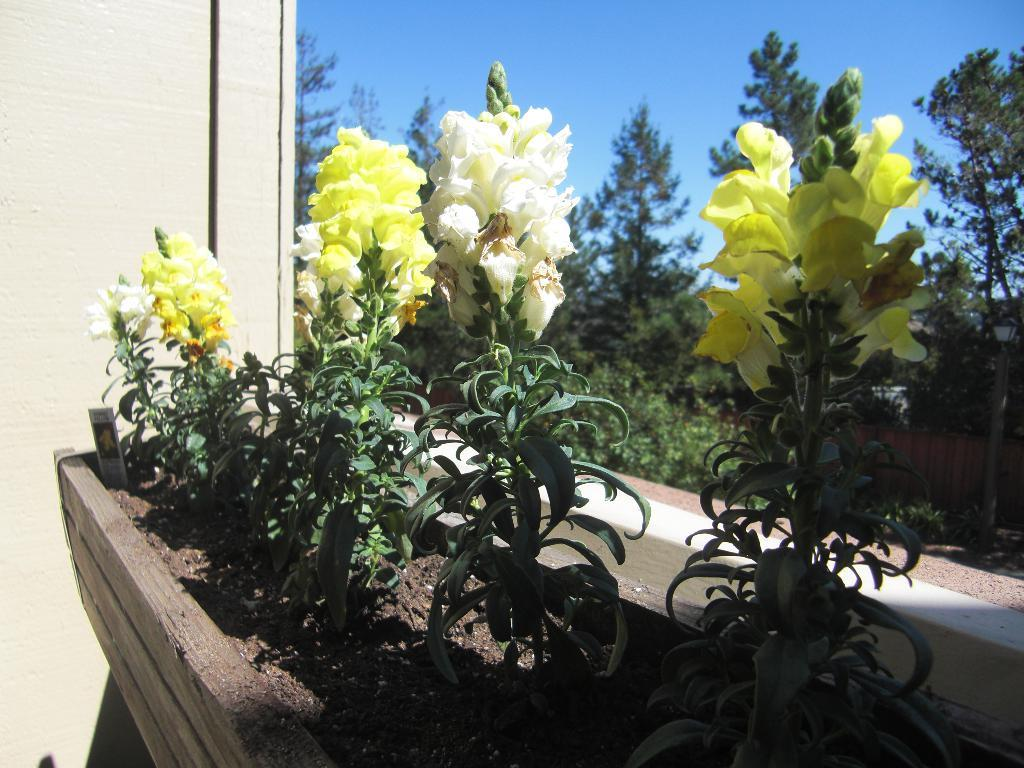What type of plants can be seen in the image? There are plants with flowers in the image. How are the plants arranged or positioned? The plants are in soil. What can be seen in the background of the image? Trees and the sky are visible in the background of the image. What color is the copper cream used to water the plants in the image? There is no copper cream or any mention of watering in the image. The plants are simply in soil. 